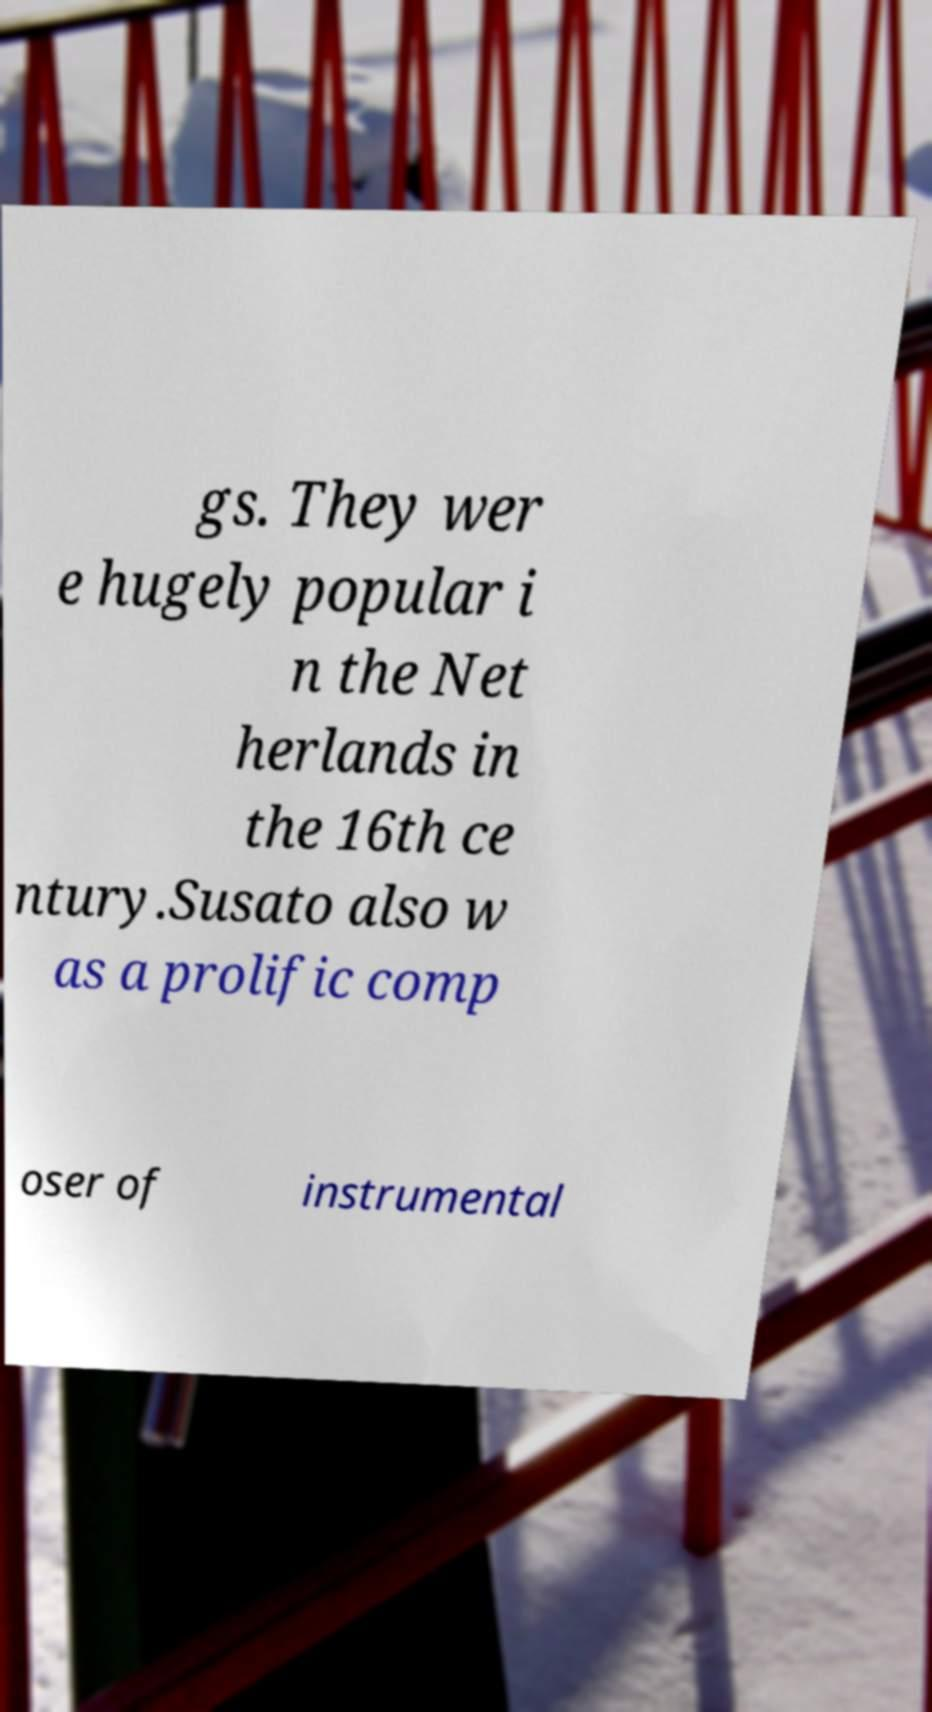Please identify and transcribe the text found in this image. gs. They wer e hugely popular i n the Net herlands in the 16th ce ntury.Susato also w as a prolific comp oser of instrumental 